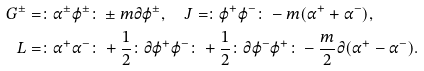<formula> <loc_0><loc_0><loc_500><loc_500>G ^ { \pm } & = \colon \alpha ^ { \pm } \varphi ^ { \pm } \colon \pm m \partial \varphi ^ { \pm } , \quad J = \colon \varphi ^ { + } \varphi ^ { - } \colon - m ( \alpha ^ { + } + \alpha ^ { - } ) , \\ L & = \colon \alpha ^ { + } \alpha ^ { - } \colon + \frac { 1 } { 2 } \colon \partial \varphi ^ { + } \varphi ^ { - } \colon + \frac { 1 } { 2 } \colon \partial \varphi ^ { - } \varphi ^ { + } \colon - \frac { m } { 2 } \partial ( \alpha ^ { + } - \alpha ^ { - } ) .</formula> 